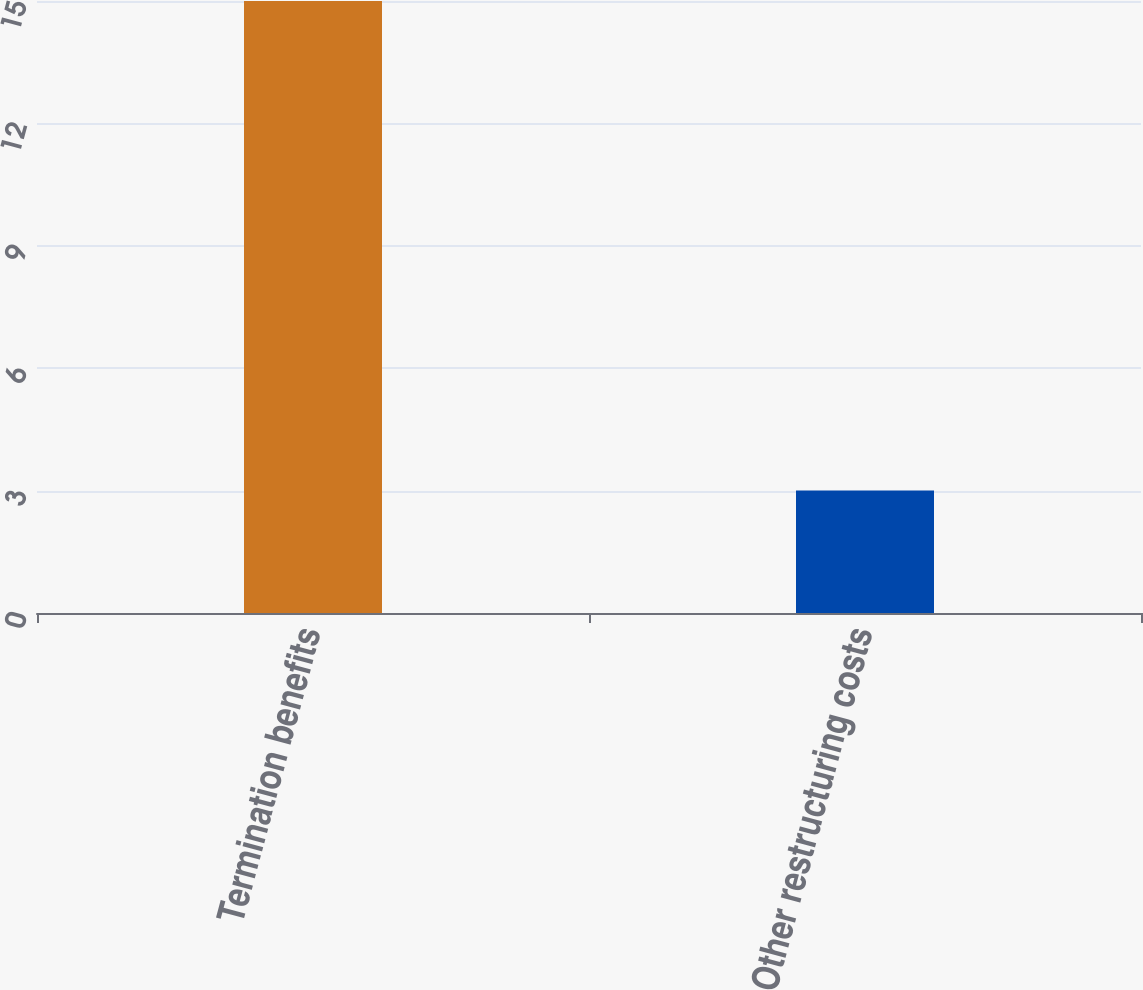<chart> <loc_0><loc_0><loc_500><loc_500><bar_chart><fcel>Termination benefits<fcel>Other restructuring costs<nl><fcel>15<fcel>3<nl></chart> 